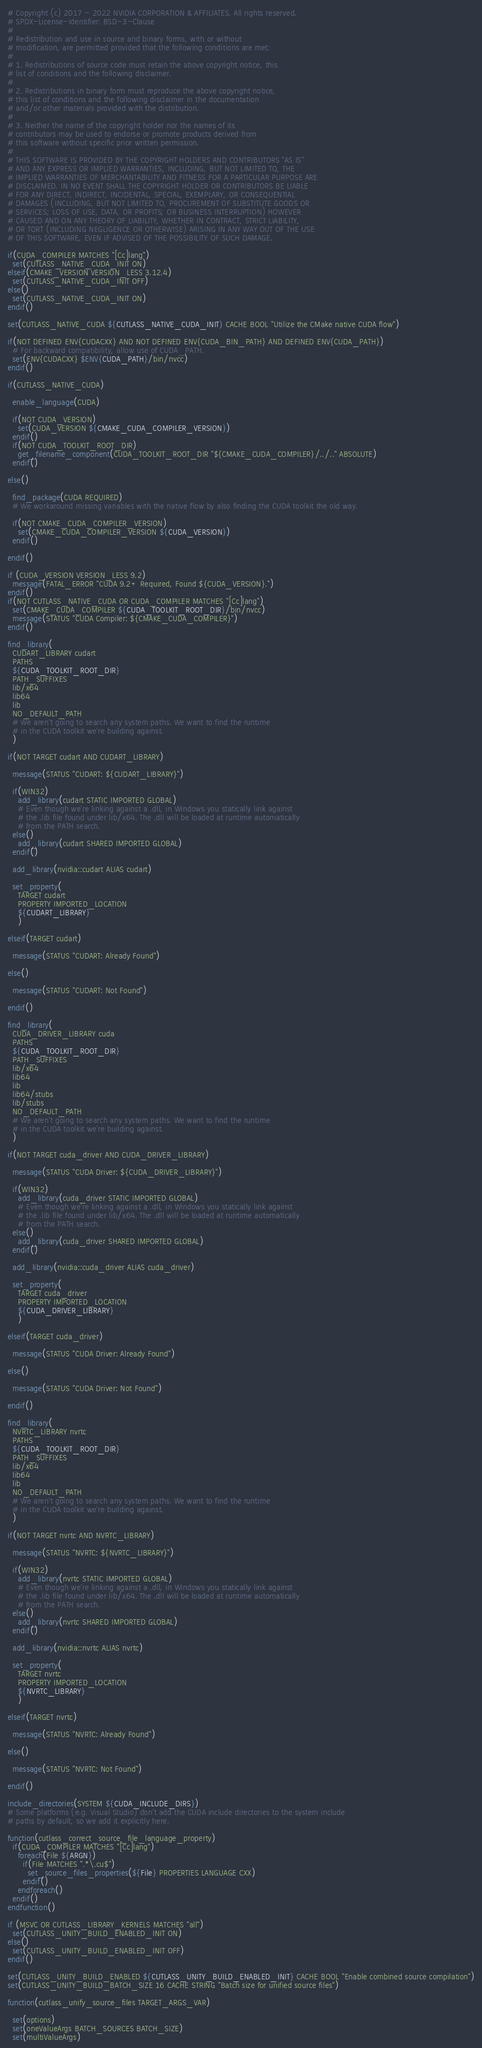Convert code to text. <code><loc_0><loc_0><loc_500><loc_500><_CMake_># Copyright (c) 2017 - 2022 NVIDIA CORPORATION & AFFILIATES. All rights reserved.
# SPDX-License-Identifier: BSD-3-Clause
#
# Redistribution and use in source and binary forms, with or without
# modification, are permitted provided that the following conditions are met:
#
# 1. Redistributions of source code must retain the above copyright notice, this
# list of conditions and the following disclaimer.
#
# 2. Redistributions in binary form must reproduce the above copyright notice,
# this list of conditions and the following disclaimer in the documentation
# and/or other materials provided with the distribution.
#
# 3. Neither the name of the copyright holder nor the names of its
# contributors may be used to endorse or promote products derived from
# this software without specific prior written permission.
#
# THIS SOFTWARE IS PROVIDED BY THE COPYRIGHT HOLDERS AND CONTRIBUTORS "AS IS"
# AND ANY EXPRESS OR IMPLIED WARRANTIES, INCLUDING, BUT NOT LIMITED TO, THE
# IMPLIED WARRANTIES OF MERCHANTABILITY AND FITNESS FOR A PARTICULAR PURPOSE ARE
# DISCLAIMED. IN NO EVENT SHALL THE COPYRIGHT HOLDER OR CONTRIBUTORS BE LIABLE
# FOR ANY DIRECT, INDIRECT, INCIDENTAL, SPECIAL, EXEMPLARY, OR CONSEQUENTIAL
# DAMAGES (INCLUDING, BUT NOT LIMITED TO, PROCUREMENT OF SUBSTITUTE GOODS OR
# SERVICES; LOSS OF USE, DATA, OR PROFITS; OR BUSINESS INTERRUPTION) HOWEVER
# CAUSED AND ON ANY THEORY OF LIABILITY, WHETHER IN CONTRACT, STRICT LIABILITY,
# OR TORT (INCLUDING NEGLIGENCE OR OTHERWISE) ARISING IN ANY WAY OUT OF THE USE
# OF THIS SOFTWARE, EVEN IF ADVISED OF THE POSSIBILITY OF SUCH DAMAGE.

if(CUDA_COMPILER MATCHES "[Cc]lang")
  set(CUTLASS_NATIVE_CUDA_INIT ON)
elseif(CMAKE_VERSION VERSION_LESS 3.12.4)
  set(CUTLASS_NATIVE_CUDA_INIT OFF)
else()
  set(CUTLASS_NATIVE_CUDA_INIT ON)
endif()

set(CUTLASS_NATIVE_CUDA ${CUTLASS_NATIVE_CUDA_INIT} CACHE BOOL "Utilize the CMake native CUDA flow")

if(NOT DEFINED ENV{CUDACXX} AND NOT DEFINED ENV{CUDA_BIN_PATH} AND DEFINED ENV{CUDA_PATH})
  # For backward compatibility, allow use of CUDA_PATH.
  set(ENV{CUDACXX} $ENV{CUDA_PATH}/bin/nvcc)
endif()

if(CUTLASS_NATIVE_CUDA)

  enable_language(CUDA)

  if(NOT CUDA_VERSION)
    set(CUDA_VERSION ${CMAKE_CUDA_COMPILER_VERSION})
  endif()
  if(NOT CUDA_TOOLKIT_ROOT_DIR)
    get_filename_component(CUDA_TOOLKIT_ROOT_DIR "${CMAKE_CUDA_COMPILER}/../.." ABSOLUTE)
  endif()

else()

  find_package(CUDA REQUIRED)
  # We workaround missing variables with the native flow by also finding the CUDA toolkit the old way.

  if(NOT CMAKE_CUDA_COMPILER_VERSION)
    set(CMAKE_CUDA_COMPILER_VERSION ${CUDA_VERSION})
  endif()

endif()

if (CUDA_VERSION VERSION_LESS 9.2)
  message(FATAL_ERROR "CUDA 9.2+ Required, Found ${CUDA_VERSION}.")
endif()
if(NOT CUTLASS_NATIVE_CUDA OR CUDA_COMPILER MATCHES "[Cc]lang")
  set(CMAKE_CUDA_COMPILER ${CUDA_TOOLKIT_ROOT_DIR}/bin/nvcc)
  message(STATUS "CUDA Compiler: ${CMAKE_CUDA_COMPILER}")
endif()

find_library(
  CUDART_LIBRARY cudart
  PATHS
  ${CUDA_TOOLKIT_ROOT_DIR}
  PATH_SUFFIXES
  lib/x64
  lib64
  lib
  NO_DEFAULT_PATH
  # We aren't going to search any system paths. We want to find the runtime
  # in the CUDA toolkit we're building against.
  )

if(NOT TARGET cudart AND CUDART_LIBRARY)

  message(STATUS "CUDART: ${CUDART_LIBRARY}")

  if(WIN32)
    add_library(cudart STATIC IMPORTED GLOBAL)
    # Even though we're linking against a .dll, in Windows you statically link against
    # the .lib file found under lib/x64. The .dll will be loaded at runtime automatically
    # from the PATH search.
  else()
    add_library(cudart SHARED IMPORTED GLOBAL)
  endif()

  add_library(nvidia::cudart ALIAS cudart)

  set_property(
    TARGET cudart
    PROPERTY IMPORTED_LOCATION
    ${CUDART_LIBRARY}
    )

elseif(TARGET cudart)

  message(STATUS "CUDART: Already Found")

else()

  message(STATUS "CUDART: Not Found")

endif()

find_library(
  CUDA_DRIVER_LIBRARY cuda
  PATHS
  ${CUDA_TOOLKIT_ROOT_DIR}
  PATH_SUFFIXES
  lib/x64
  lib64
  lib
  lib64/stubs
  lib/stubs
  NO_DEFAULT_PATH
  # We aren't going to search any system paths. We want to find the runtime
  # in the CUDA toolkit we're building against.
  )

if(NOT TARGET cuda_driver AND CUDA_DRIVER_LIBRARY)

  message(STATUS "CUDA Driver: ${CUDA_DRIVER_LIBRARY}")

  if(WIN32)
    add_library(cuda_driver STATIC IMPORTED GLOBAL)
    # Even though we're linking against a .dll, in Windows you statically link against
    # the .lib file found under lib/x64. The .dll will be loaded at runtime automatically
    # from the PATH search.
  else()
    add_library(cuda_driver SHARED IMPORTED GLOBAL)
  endif()

  add_library(nvidia::cuda_driver ALIAS cuda_driver)

  set_property(
    TARGET cuda_driver
    PROPERTY IMPORTED_LOCATION
    ${CUDA_DRIVER_LIBRARY}
    )

elseif(TARGET cuda_driver)

  message(STATUS "CUDA Driver: Already Found")

else()

  message(STATUS "CUDA Driver: Not Found")

endif()

find_library(
  NVRTC_LIBRARY nvrtc
  PATHS
  ${CUDA_TOOLKIT_ROOT_DIR}
  PATH_SUFFIXES
  lib/x64
  lib64
  lib
  NO_DEFAULT_PATH
  # We aren't going to search any system paths. We want to find the runtime
  # in the CUDA toolkit we're building against.
  )

if(NOT TARGET nvrtc AND NVRTC_LIBRARY)

  message(STATUS "NVRTC: ${NVRTC_LIBRARY}")

  if(WIN32)
    add_library(nvrtc STATIC IMPORTED GLOBAL)
    # Even though we're linking against a .dll, in Windows you statically link against
    # the .lib file found under lib/x64. The .dll will be loaded at runtime automatically
    # from the PATH search.
  else()
    add_library(nvrtc SHARED IMPORTED GLOBAL)
  endif()

  add_library(nvidia::nvrtc ALIAS nvrtc)

  set_property(
    TARGET nvrtc
    PROPERTY IMPORTED_LOCATION
    ${NVRTC_LIBRARY}
    )

elseif(TARGET nvrtc)

  message(STATUS "NVRTC: Already Found")

else()

  message(STATUS "NVRTC: Not Found")

endif()

include_directories(SYSTEM ${CUDA_INCLUDE_DIRS})
# Some platforms (e.g. Visual Studio) don't add the CUDA include directories to the system include
# paths by default, so we add it explicitly here.

function(cutlass_correct_source_file_language_property)
  if(CUDA_COMPILER MATCHES "[Cc]lang")
    foreach(File ${ARGN})
      if(File MATCHES ".*\.cu$")
        set_source_files_properties(${File} PROPERTIES LANGUAGE CXX)
      endif()
    endforeach()
  endif()
endfunction()

if (MSVC OR CUTLASS_LIBRARY_KERNELS MATCHES "all")
  set(CUTLASS_UNITY_BUILD_ENABLED_INIT ON)
else()
  set(CUTLASS_UNITY_BUILD_ENABLED_INIT OFF)
endif()

set(CUTLASS_UNITY_BUILD_ENABLED ${CUTLASS_UNITY_BUILD_ENABLED_INIT} CACHE BOOL "Enable combined source compilation")
set(CUTLASS_UNITY_BUILD_BATCH_SIZE 16 CACHE STRING "Batch size for unified source files")

function(cutlass_unify_source_files TARGET_ARGS_VAR)

  set(options)
  set(oneValueArgs BATCH_SOURCES BATCH_SIZE)
  set(multiValueArgs)</code> 